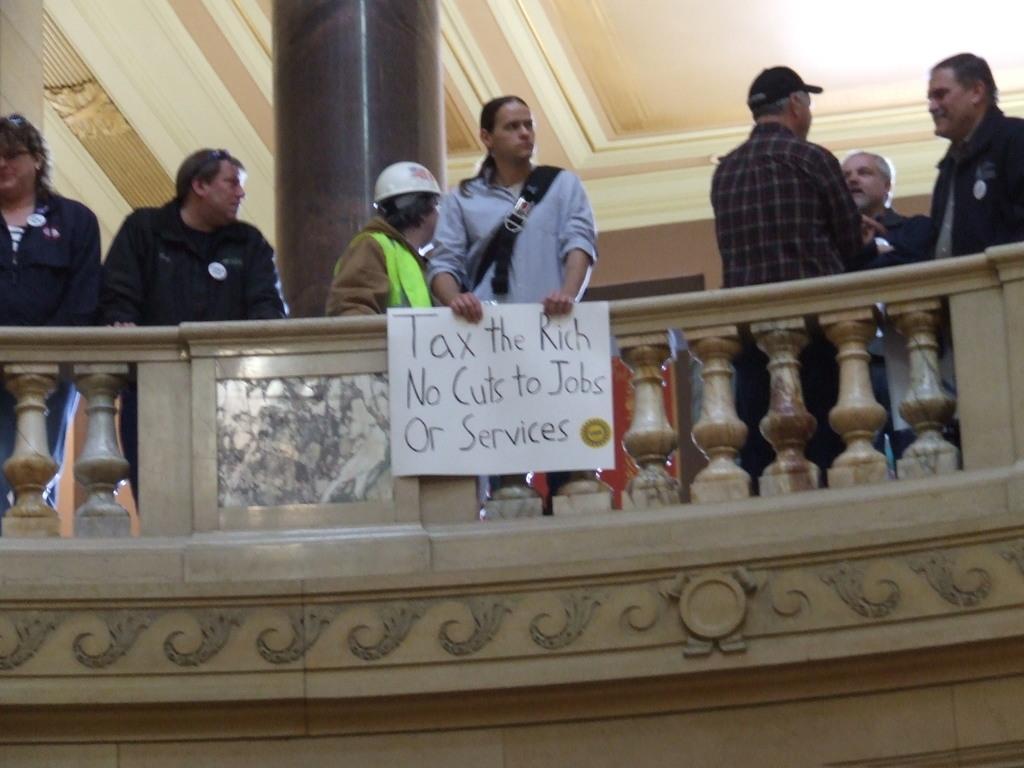Could you give a brief overview of what you see in this image? In this image I can see in the middle a person is standing by holding the placard. Few people are standing around him, in the middle it looks like a railing. 